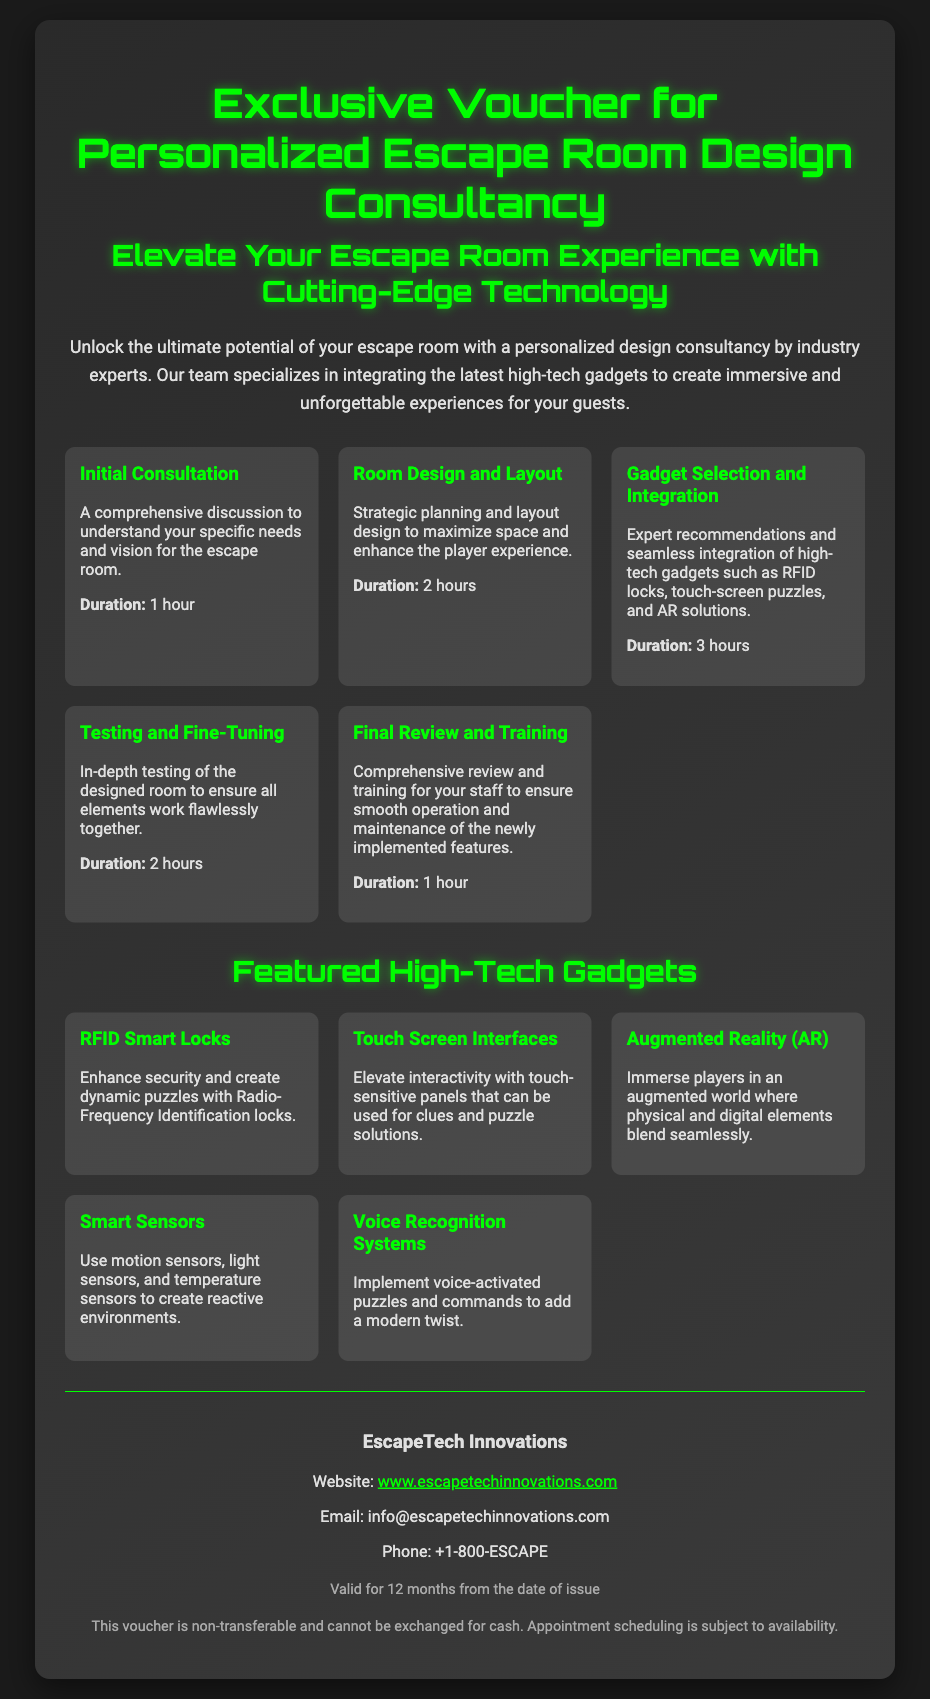what is the title of the voucher? The title of the voucher is prominently displayed at the top of the document.
Answer: Exclusive Voucher for Personalized Escape Room Design Consultancy how long is the initial consultation? The duration for the initial consultation is provided in the services section of the document.
Answer: 1 hour which high-tech gadget allows for creating dynamic puzzles? This gadget is listed in the featured gadgets section that enhances security and puzzle interactivity.
Answer: RFID Smart Locks what is the purpose of the final review and training service? The final review and training service is detailed in the services section and addresses the operational aspects for staff.
Answer: To ensure smooth operation and maintenance how long is the validity period of the voucher? The validity period is specified at the end of the document.
Answer: 12 months what is the contact website for EscapeTech Innovations? The contact information section includes a website link for inquiries.
Answer: www.escapetechinnovations.com how many featured high-tech gadgets are mentioned? The number of gadgets is determined by counting the unique entries in the gadgets section.
Answer: 5 what type of technology can be integrated for augmented experiences? This is addressed in the featured gadget section discussing immersive technologies.
Answer: Augmented Reality (AR) 